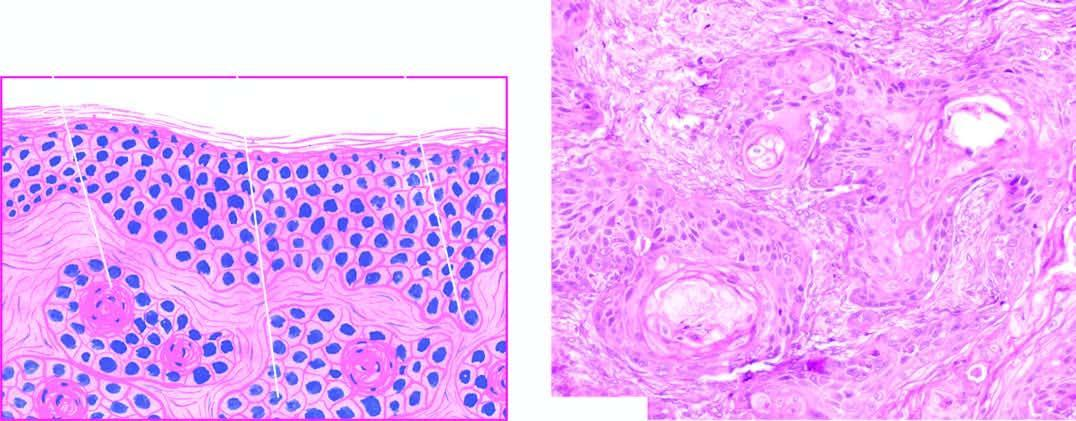what is invaded by downward proliferating epidermal masses of cells which show atypical features?
Answer the question using a single word or phrase. Dermis 